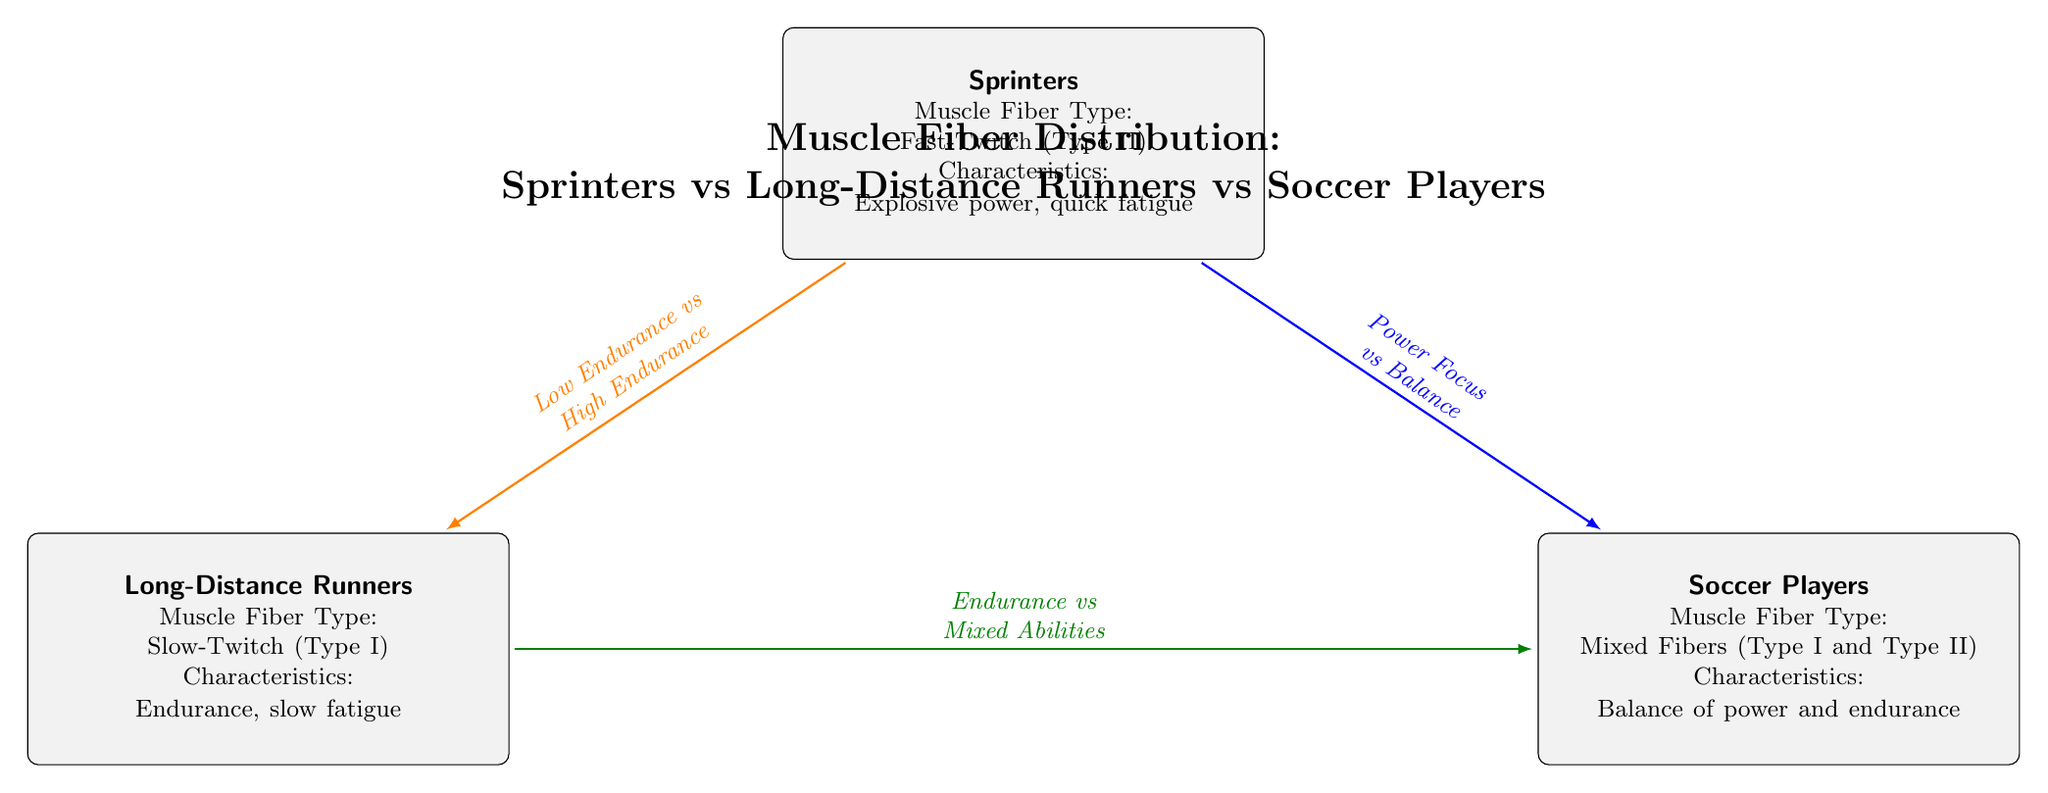What type of muscle fiber do sprinters primarily have? The diagram states that sprinters have Fast-Twitch (Type II) muscle fibers. This information is clearly indicated under the Sprinters node.
Answer: Fast-Twitch (Type II) What are the characteristics of long-distance runners? The characteristics of long-distance runners are listed as "Endurance, slow fatigue" under the Long-Distance Runners node. This provides precise insight into the capabilities of this group.
Answer: Endurance, slow fatigue How do sprinters and soccer players differ in muscle fiber focus? According to the diagram, sprinters focus primarily on power whereas soccer players have a balance of power and endurance. This relationship is indicated by the blue line connecting the two nodes.
Answer: Power Focus vs Balance Which athlete group shows low endurance characteristics? The diagram specifies that sprinters have low endurance characteristics, as represented in the node and further emphasized by the orange line to the long-distance runners node.
Answer: Sprinters What muscle fiber types do soccer players possess? The diagram states that soccer players have Mixed Fibers, specifically Type I and Type II. This detail is clearly presented under the Soccer Players node.
Answer: Mixed Fibers (Type I and Type II) What is the relationship between endurance characteristics of long-distance runners and soccer players? The diagram illustrates that long-distance runners show high endurance characteristics while soccer players exhibit mixed abilities. This connection is detailed by the green line between the two nodes.
Answer: Endurance vs Mixed Abilities 